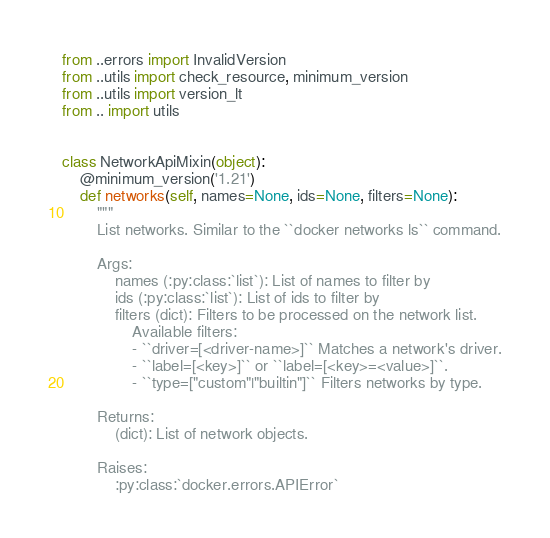Convert code to text. <code><loc_0><loc_0><loc_500><loc_500><_Python_>from ..errors import InvalidVersion
from ..utils import check_resource, minimum_version
from ..utils import version_lt
from .. import utils


class NetworkApiMixin(object):
    @minimum_version('1.21')
    def networks(self, names=None, ids=None, filters=None):
        """
        List networks. Similar to the ``docker networks ls`` command.

        Args:
            names (:py:class:`list`): List of names to filter by
            ids (:py:class:`list`): List of ids to filter by
            filters (dict): Filters to be processed on the network list.
                Available filters:
                - ``driver=[<driver-name>]`` Matches a network's driver.
                - ``label=[<key>]`` or ``label=[<key>=<value>]``.
                - ``type=["custom"|"builtin"]`` Filters networks by type.

        Returns:
            (dict): List of network objects.

        Raises:
            :py:class:`docker.errors.APIError`</code> 